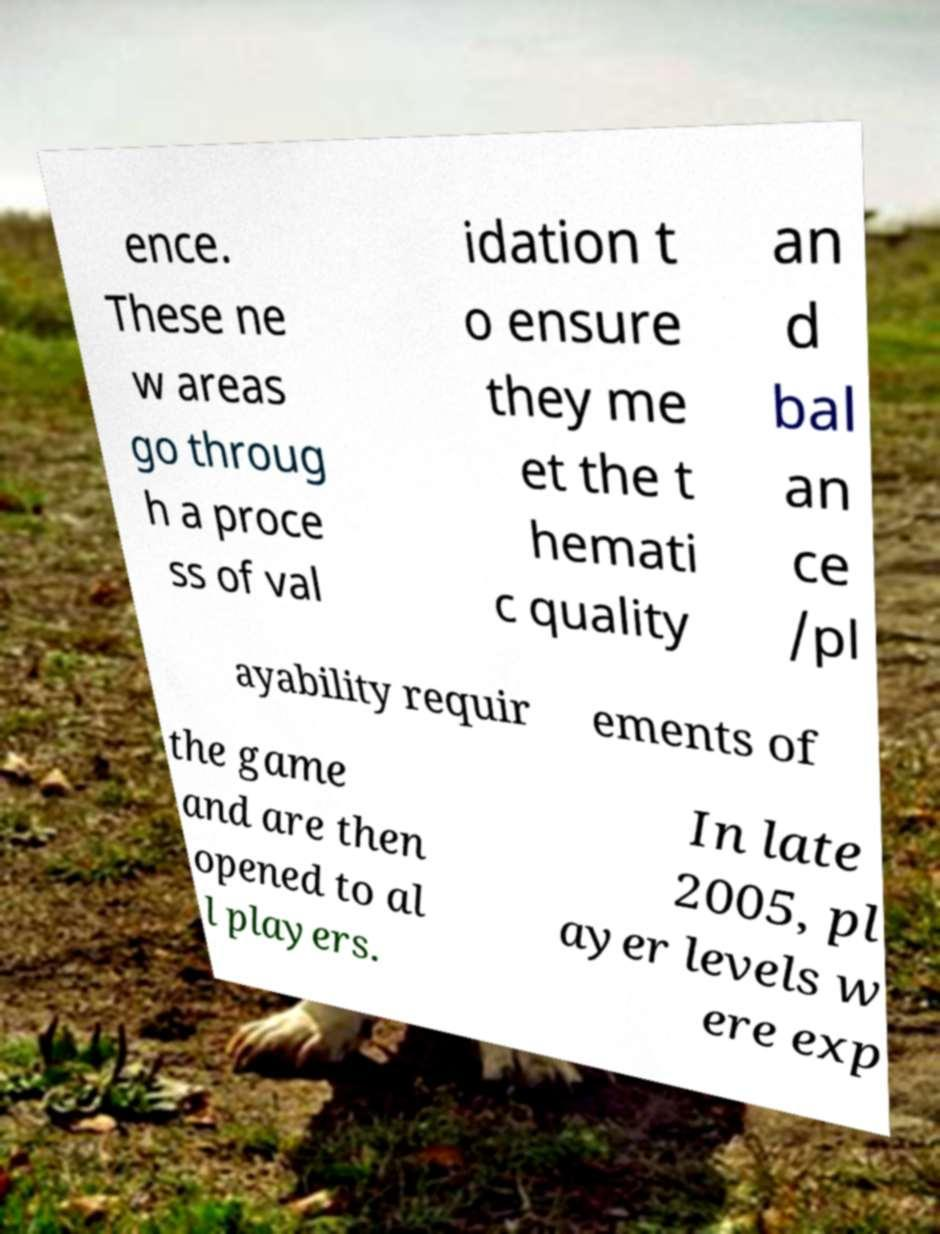Could you assist in decoding the text presented in this image and type it out clearly? ence. These ne w areas go throug h a proce ss of val idation t o ensure they me et the t hemati c quality an d bal an ce /pl ayability requir ements of the game and are then opened to al l players. In late 2005, pl ayer levels w ere exp 